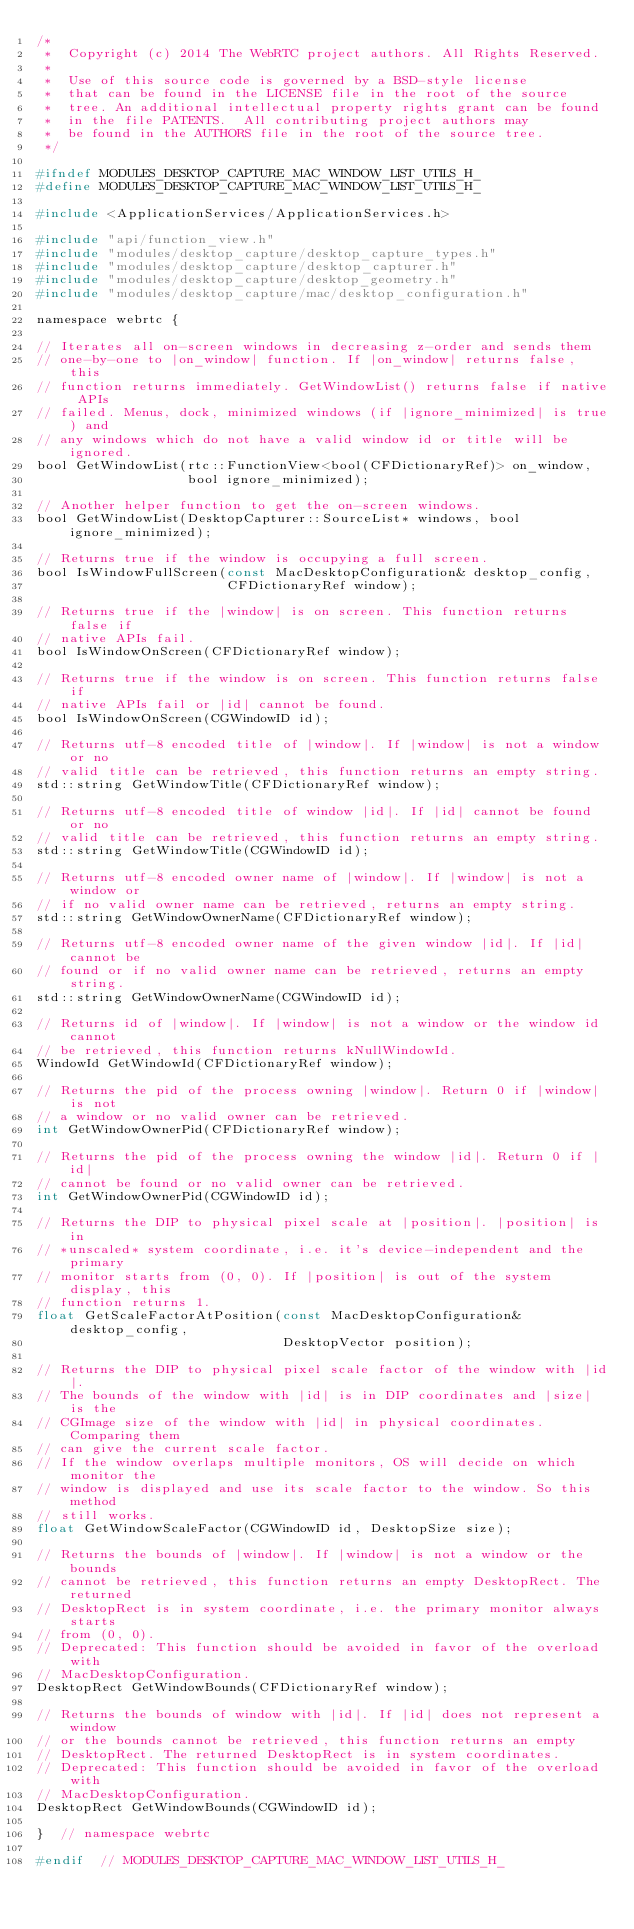Convert code to text. <code><loc_0><loc_0><loc_500><loc_500><_C_>/*
 *  Copyright (c) 2014 The WebRTC project authors. All Rights Reserved.
 *
 *  Use of this source code is governed by a BSD-style license
 *  that can be found in the LICENSE file in the root of the source
 *  tree. An additional intellectual property rights grant can be found
 *  in the file PATENTS.  All contributing project authors may
 *  be found in the AUTHORS file in the root of the source tree.
 */

#ifndef MODULES_DESKTOP_CAPTURE_MAC_WINDOW_LIST_UTILS_H_
#define MODULES_DESKTOP_CAPTURE_MAC_WINDOW_LIST_UTILS_H_

#include <ApplicationServices/ApplicationServices.h>

#include "api/function_view.h"
#include "modules/desktop_capture/desktop_capture_types.h"
#include "modules/desktop_capture/desktop_capturer.h"
#include "modules/desktop_capture/desktop_geometry.h"
#include "modules/desktop_capture/mac/desktop_configuration.h"

namespace webrtc {

// Iterates all on-screen windows in decreasing z-order and sends them
// one-by-one to |on_window| function. If |on_window| returns false, this
// function returns immediately. GetWindowList() returns false if native APIs
// failed. Menus, dock, minimized windows (if |ignore_minimized| is true) and
// any windows which do not have a valid window id or title will be ignored.
bool GetWindowList(rtc::FunctionView<bool(CFDictionaryRef)> on_window,
                   bool ignore_minimized);

// Another helper function to get the on-screen windows.
bool GetWindowList(DesktopCapturer::SourceList* windows, bool ignore_minimized);

// Returns true if the window is occupying a full screen.
bool IsWindowFullScreen(const MacDesktopConfiguration& desktop_config,
                        CFDictionaryRef window);

// Returns true if the |window| is on screen. This function returns false if
// native APIs fail.
bool IsWindowOnScreen(CFDictionaryRef window);

// Returns true if the window is on screen. This function returns false if
// native APIs fail or |id| cannot be found.
bool IsWindowOnScreen(CGWindowID id);

// Returns utf-8 encoded title of |window|. If |window| is not a window or no
// valid title can be retrieved, this function returns an empty string.
std::string GetWindowTitle(CFDictionaryRef window);

// Returns utf-8 encoded title of window |id|. If |id| cannot be found or no
// valid title can be retrieved, this function returns an empty string.
std::string GetWindowTitle(CGWindowID id);

// Returns utf-8 encoded owner name of |window|. If |window| is not a window or
// if no valid owner name can be retrieved, returns an empty string.
std::string GetWindowOwnerName(CFDictionaryRef window);

// Returns utf-8 encoded owner name of the given window |id|. If |id| cannot be
// found or if no valid owner name can be retrieved, returns an empty string.
std::string GetWindowOwnerName(CGWindowID id);

// Returns id of |window|. If |window| is not a window or the window id cannot
// be retrieved, this function returns kNullWindowId.
WindowId GetWindowId(CFDictionaryRef window);

// Returns the pid of the process owning |window|. Return 0 if |window| is not
// a window or no valid owner can be retrieved.
int GetWindowOwnerPid(CFDictionaryRef window);

// Returns the pid of the process owning the window |id|. Return 0 if |id|
// cannot be found or no valid owner can be retrieved.
int GetWindowOwnerPid(CGWindowID id);

// Returns the DIP to physical pixel scale at |position|. |position| is in
// *unscaled* system coordinate, i.e. it's device-independent and the primary
// monitor starts from (0, 0). If |position| is out of the system display, this
// function returns 1.
float GetScaleFactorAtPosition(const MacDesktopConfiguration& desktop_config,
                               DesktopVector position);

// Returns the DIP to physical pixel scale factor of the window with |id|.
// The bounds of the window with |id| is in DIP coordinates and |size| is the
// CGImage size of the window with |id| in physical coordinates. Comparing them
// can give the current scale factor.
// If the window overlaps multiple monitors, OS will decide on which monitor the
// window is displayed and use its scale factor to the window. So this method
// still works.
float GetWindowScaleFactor(CGWindowID id, DesktopSize size);

// Returns the bounds of |window|. If |window| is not a window or the bounds
// cannot be retrieved, this function returns an empty DesktopRect. The returned
// DesktopRect is in system coordinate, i.e. the primary monitor always starts
// from (0, 0).
// Deprecated: This function should be avoided in favor of the overload with
// MacDesktopConfiguration.
DesktopRect GetWindowBounds(CFDictionaryRef window);

// Returns the bounds of window with |id|. If |id| does not represent a window
// or the bounds cannot be retrieved, this function returns an empty
// DesktopRect. The returned DesktopRect is in system coordinates.
// Deprecated: This function should be avoided in favor of the overload with
// MacDesktopConfiguration.
DesktopRect GetWindowBounds(CGWindowID id);

}  // namespace webrtc

#endif  // MODULES_DESKTOP_CAPTURE_MAC_WINDOW_LIST_UTILS_H_
</code> 